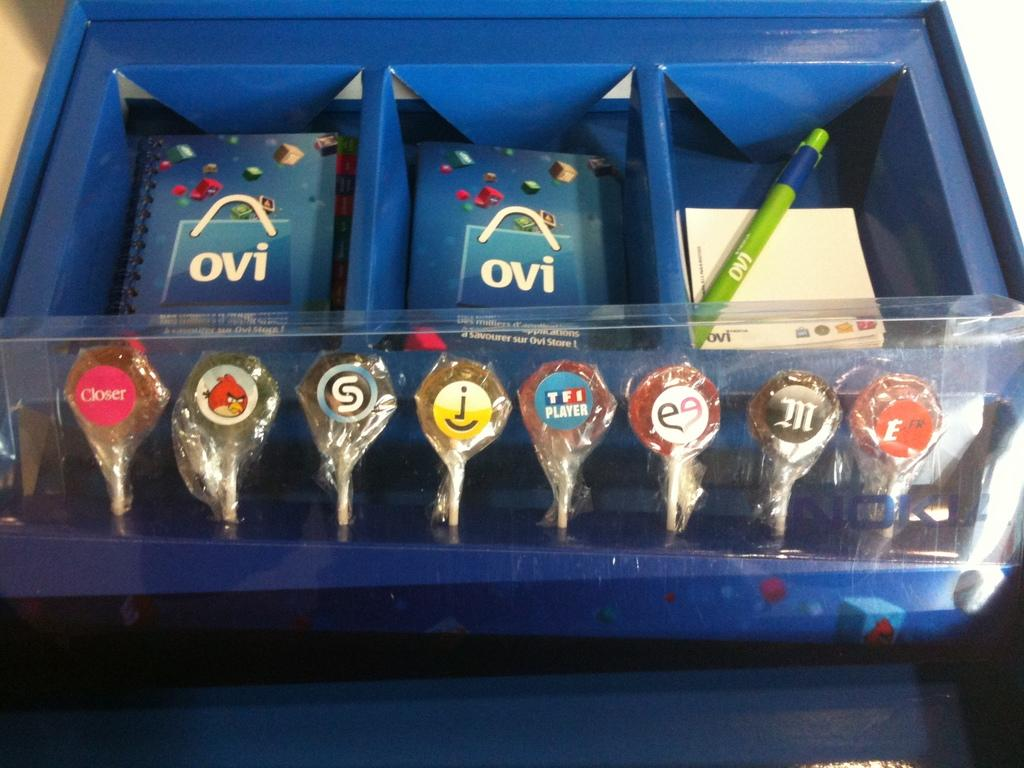<image>
Provide a brief description of the given image. Blue notepad with the word OVI on the front cover. 